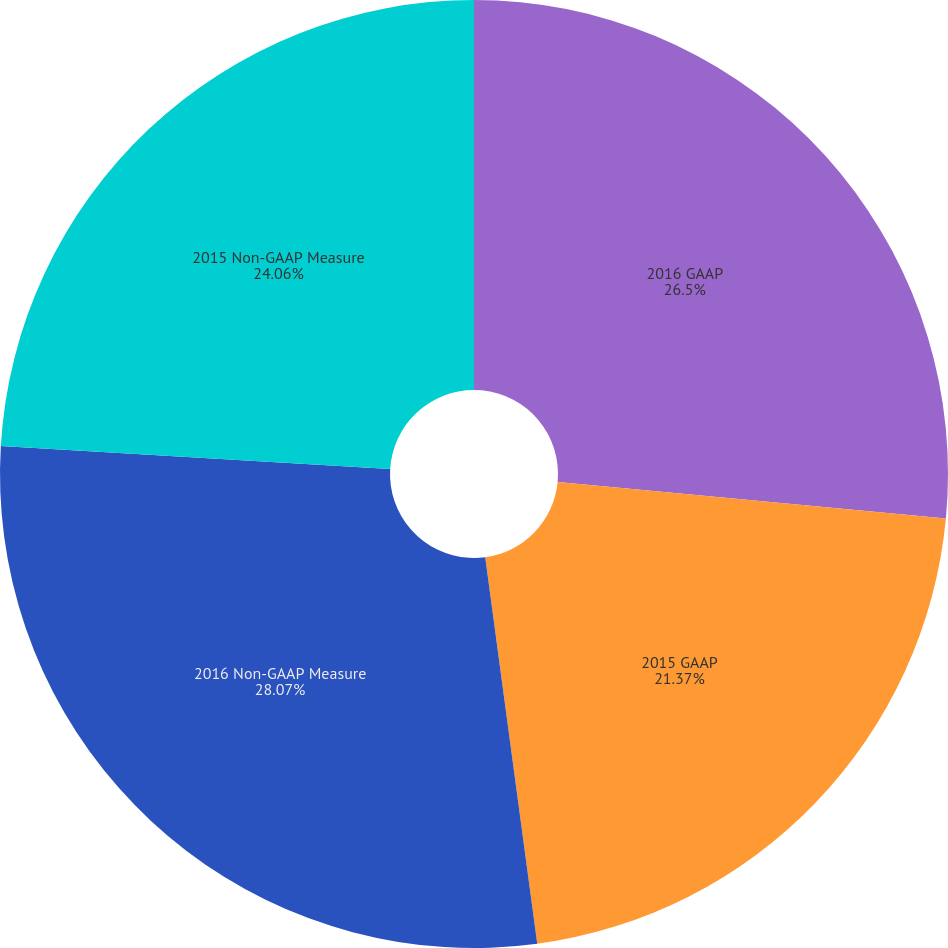Convert chart. <chart><loc_0><loc_0><loc_500><loc_500><pie_chart><fcel>2016 GAAP<fcel>2015 GAAP<fcel>2016 Non-GAAP Measure<fcel>2015 Non-GAAP Measure<nl><fcel>26.5%<fcel>21.37%<fcel>28.07%<fcel>24.06%<nl></chart> 